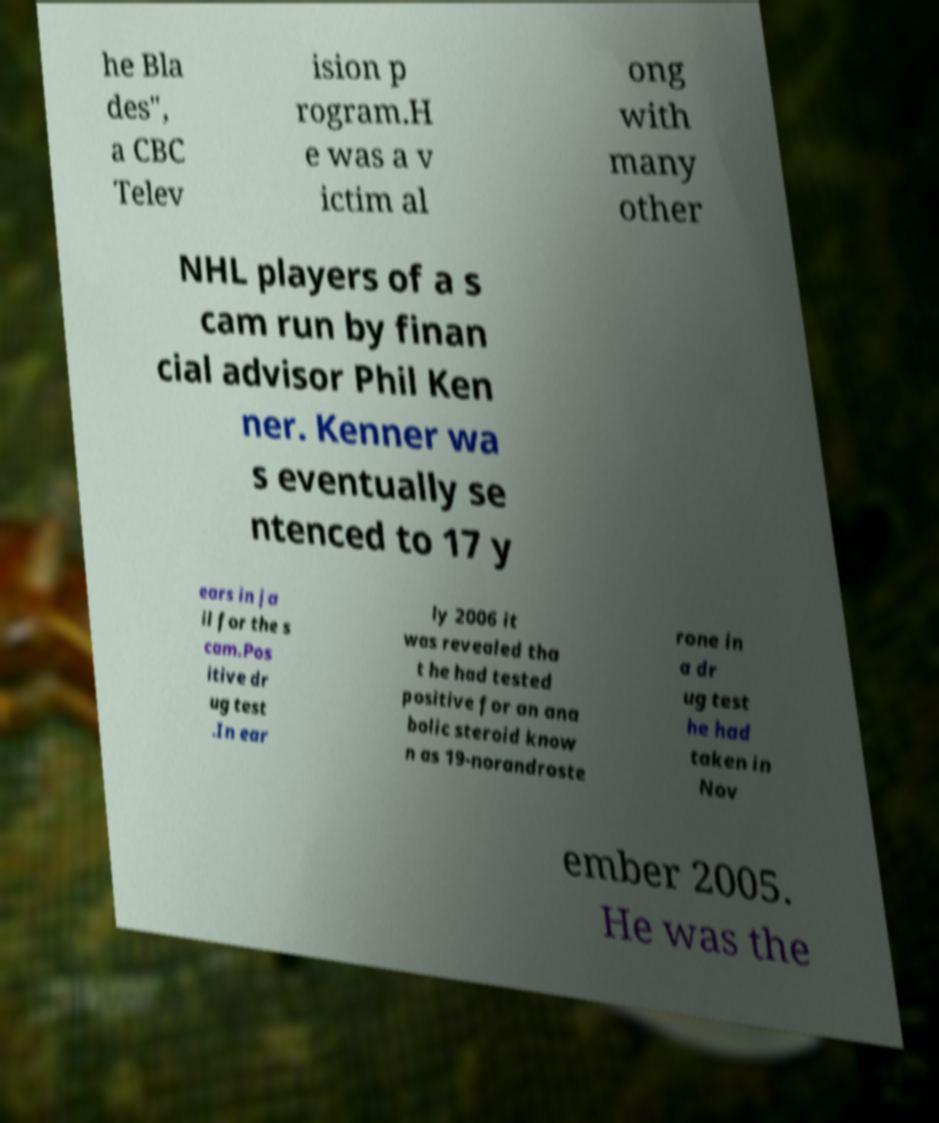There's text embedded in this image that I need extracted. Can you transcribe it verbatim? he Bla des", a CBC Telev ision p rogram.H e was a v ictim al ong with many other NHL players of a s cam run by finan cial advisor Phil Ken ner. Kenner wa s eventually se ntenced to 17 y ears in ja il for the s cam.Pos itive dr ug test .In ear ly 2006 it was revealed tha t he had tested positive for an ana bolic steroid know n as 19-norandroste rone in a dr ug test he had taken in Nov ember 2005. He was the 